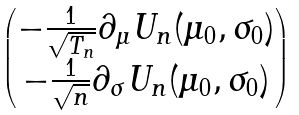<formula> <loc_0><loc_0><loc_500><loc_500>\begin{pmatrix} - \frac { 1 } { \sqrt { T _ { n } } } \partial _ { \mu } U _ { n } ( \mu _ { 0 } , \sigma _ { 0 } ) \\ - \frac { 1 } { \sqrt { n } } \partial _ { \sigma } U _ { n } ( \mu _ { 0 } , \sigma _ { 0 } ) \end{pmatrix}</formula> 